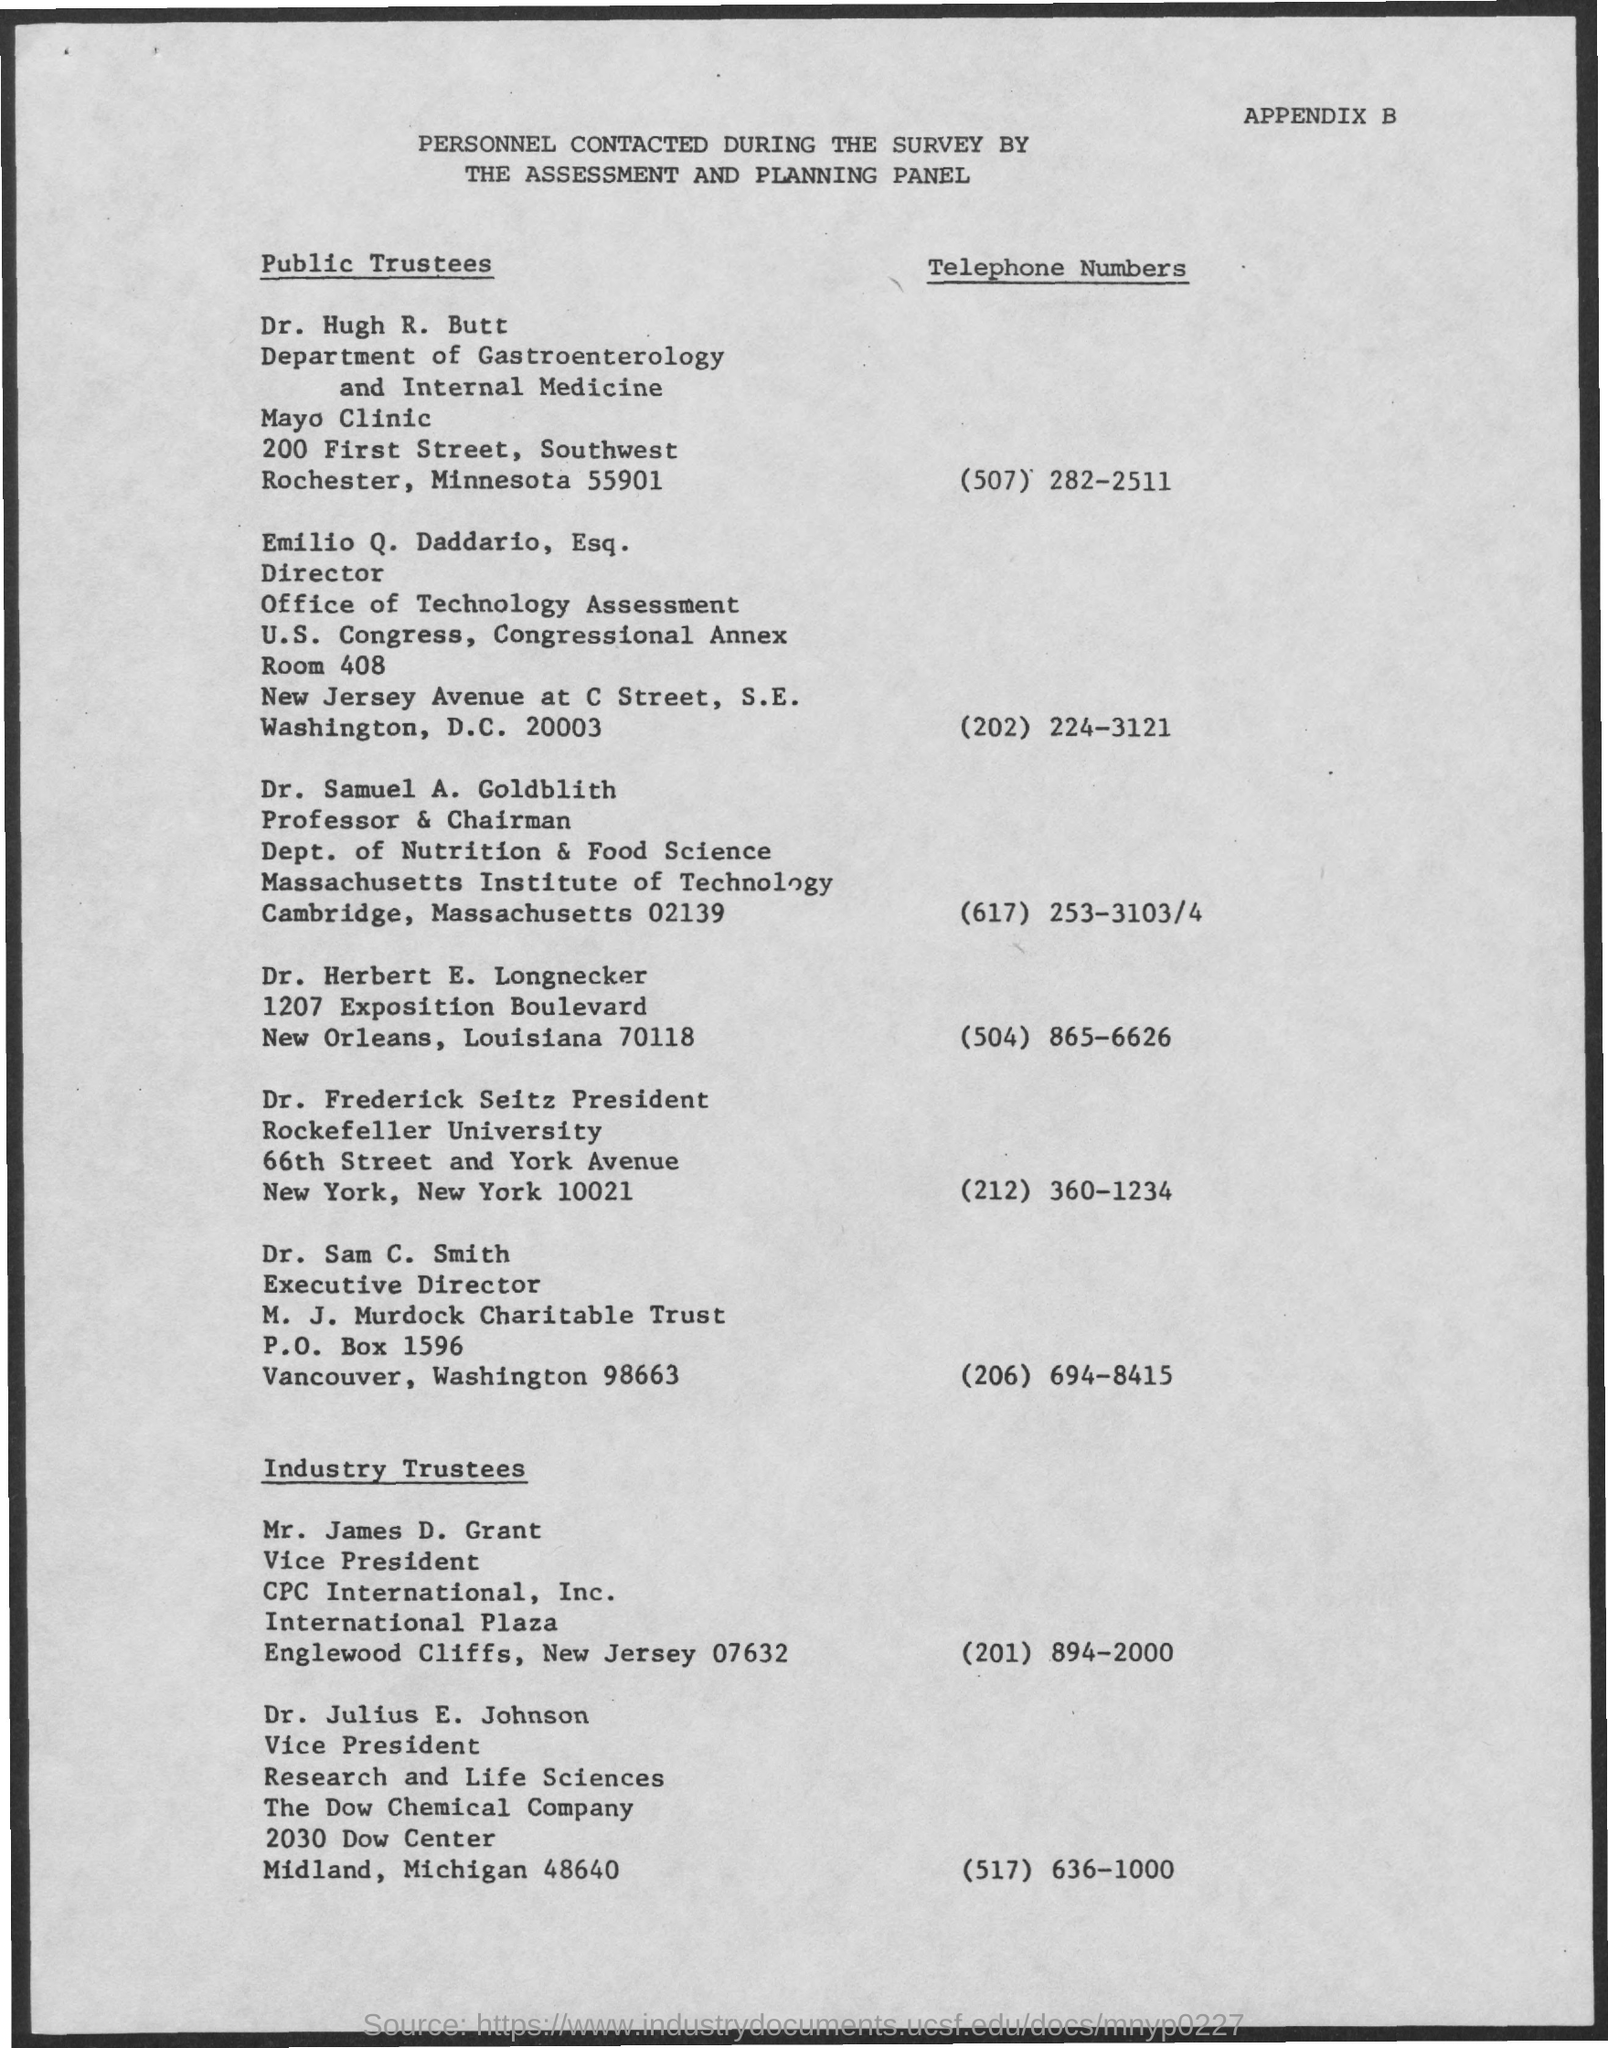Outline some significant characteristics in this image. The telephone number of Dr. Sam C. Smith is (206) 694-8415. Dr. Samuel A. Goldblith is a Professor and Chairman, with a designation of that title. 